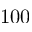Convert formula to latex. <formula><loc_0><loc_0><loc_500><loc_500>1 0 0</formula> 